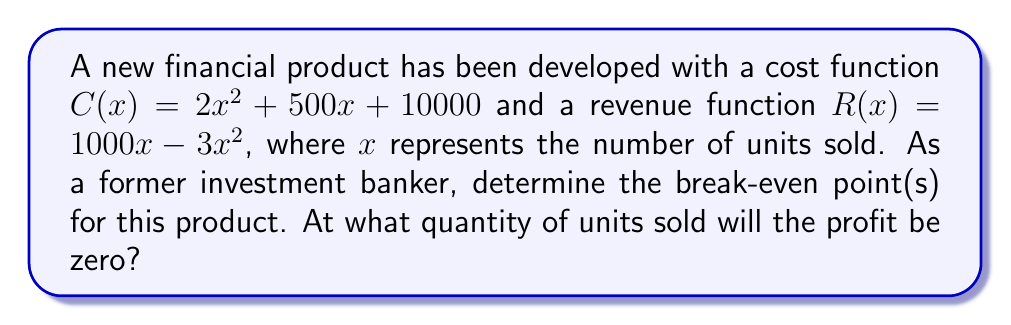Give your solution to this math problem. To find the break-even point, we need to determine where the profit is zero. Profit is defined as revenue minus cost.

Step 1: Set up the profit function
$P(x) = R(x) - C(x)$
$P(x) = (1000x - 3x^2) - (2x^2 + 500x + 10000)$

Step 2: Simplify the profit function
$P(x) = 1000x - 3x^2 - 2x^2 - 500x - 10000$
$P(x) = -5x^2 + 500x - 10000$

Step 3: Set the profit function equal to zero to find the break-even point
$-5x^2 + 500x - 10000 = 0$

Step 4: Solve the quadratic equation using the quadratic formula
$a = -5$, $b = 500$, $c = -10000$

$x = \frac{-b \pm \sqrt{b^2 - 4ac}}{2a}$

$x = \frac{-500 \pm \sqrt{500^2 - 4(-5)(-10000)}}{2(-5)}$

$x = \frac{-500 \pm \sqrt{250000 - 200000}}{-10}$

$x = \frac{-500 \pm \sqrt{50000}}{-10}$

$x = \frac{-500 \pm 223.61}{-10}$

Step 5: Calculate the two solutions
$x_1 = \frac{-500 + 223.61}{-10} \approx 27.64$
$x_2 = \frac{-500 - 223.61}{-10} \approx 72.36$

The break-even points occur at approximately 27.64 and 72.36 units sold.
Answer: 27.64 units and 72.36 units 